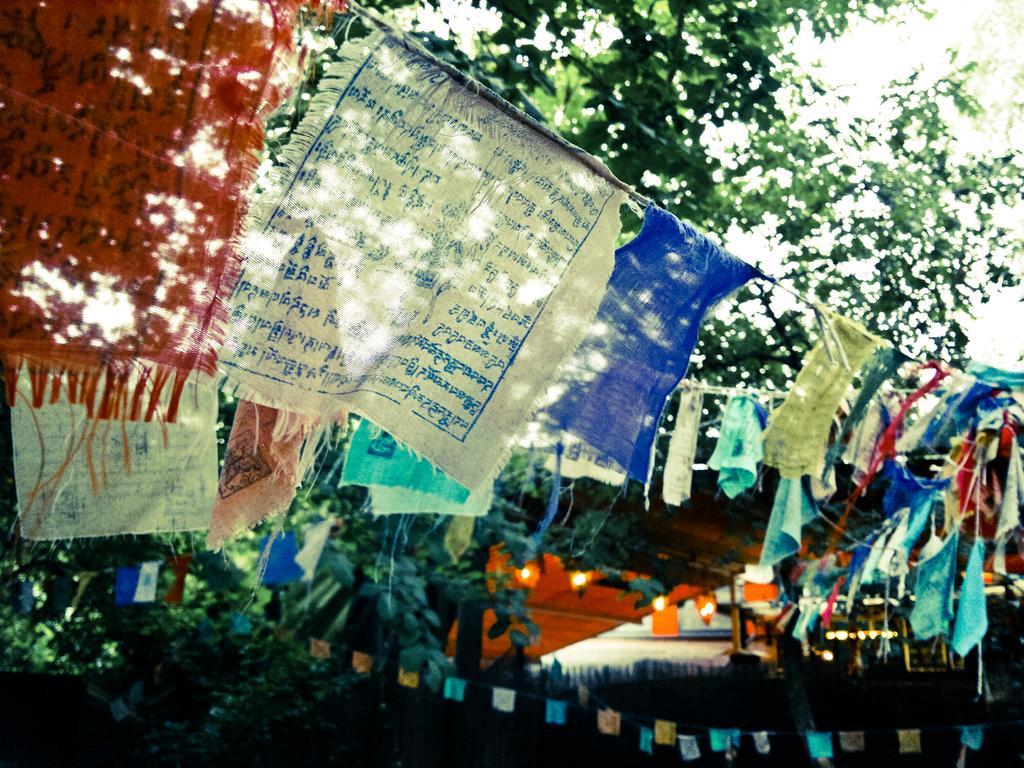Can you describe this image briefly? In this image there are flags to the rope. There is text on the flags. In the background there are leaves of a tree. At the bottom there are lights. 